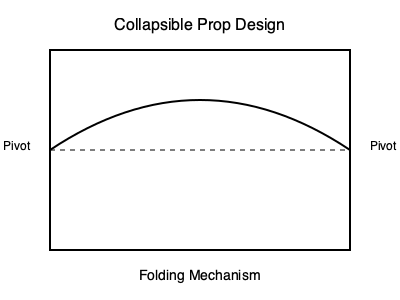In designing a collapsible prop for your vaudeville act, you need to calculate the maximum height of the arc when fully extended. If the prop is 3 meters long when flat and the pivots are fixed at both ends, what is the maximum height of the arc in centimeters, assuming it forms a perfect semi-circle when fully extended? To solve this problem, let's approach it step-by-step:

1. Visualize the prop as a semi-circle when fully extended.
2. The length of the prop (3 meters) represents the diameter of this circle.
3. We need to find the radius of the circle, which will be half the diameter:
   Radius = $\frac{3}{2}$ meters = 1.5 meters

4. The maximum height of the arc will be the radius of the semi-circle.
5. We need to convert this to centimeters:
   Height = 1.5 meters × 100 cm/m = 150 cm

6. To verify, we can use the formula for the area of a semi-circle:
   Area = $\frac{\pi r^2}{2}$

   Where $r$ is the radius (1.5 meters).

7. Substituting the values:
   Area = $\frac{\pi (1.5)^2}{2}$ = $\frac{9\pi}{4}$ ≈ 7.07 square meters

This area represents the space your prop will occupy when fully extended, which is crucial for stage planning in your vaudeville act.
Answer: 150 cm 